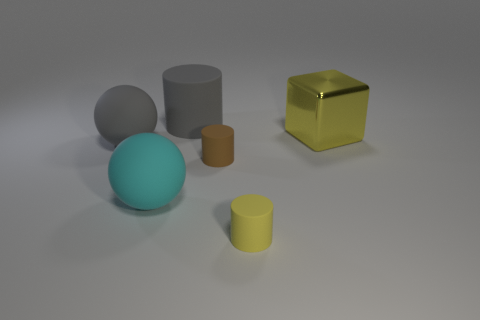Is there any other thing that is the same shape as the yellow metal thing?
Provide a succinct answer. No. What is the color of the other matte object that is the same shape as the big cyan thing?
Offer a very short reply. Gray. Is the shape of the big yellow metallic thing the same as the small yellow object?
Provide a short and direct response. No. How many balls are large things or brown matte objects?
Your response must be concise. 2. What color is the other sphere that is made of the same material as the big gray sphere?
Your answer should be very brief. Cyan. There is a object that is in front of the cyan ball; is it the same size as the metallic thing?
Offer a very short reply. No. Is the large cube made of the same material as the gray object to the left of the big matte cylinder?
Give a very brief answer. No. What color is the big thing in front of the tiny brown rubber cylinder?
Provide a succinct answer. Cyan. There is a cyan rubber sphere to the left of the yellow metal object; are there any tiny yellow rubber things behind it?
Your answer should be compact. No. Does the tiny rubber cylinder to the left of the yellow rubber cylinder have the same color as the tiny rubber thing in front of the big cyan matte ball?
Your response must be concise. No. 